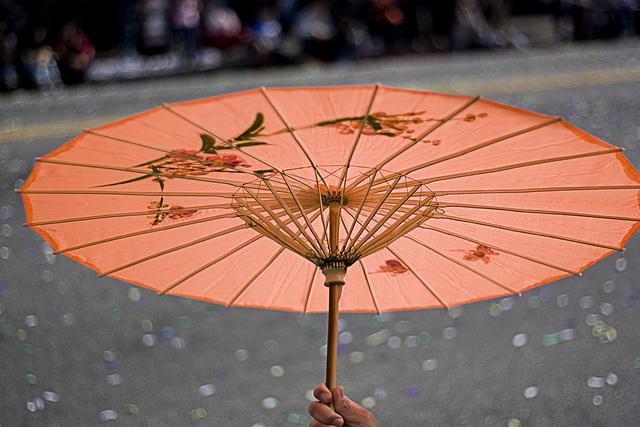What is the handle of the umbrella made with?
Quick response, please. Wood. Is the umbrella open?
Give a very brief answer. Yes. What color is the umbrella?
Quick response, please. Orange. 